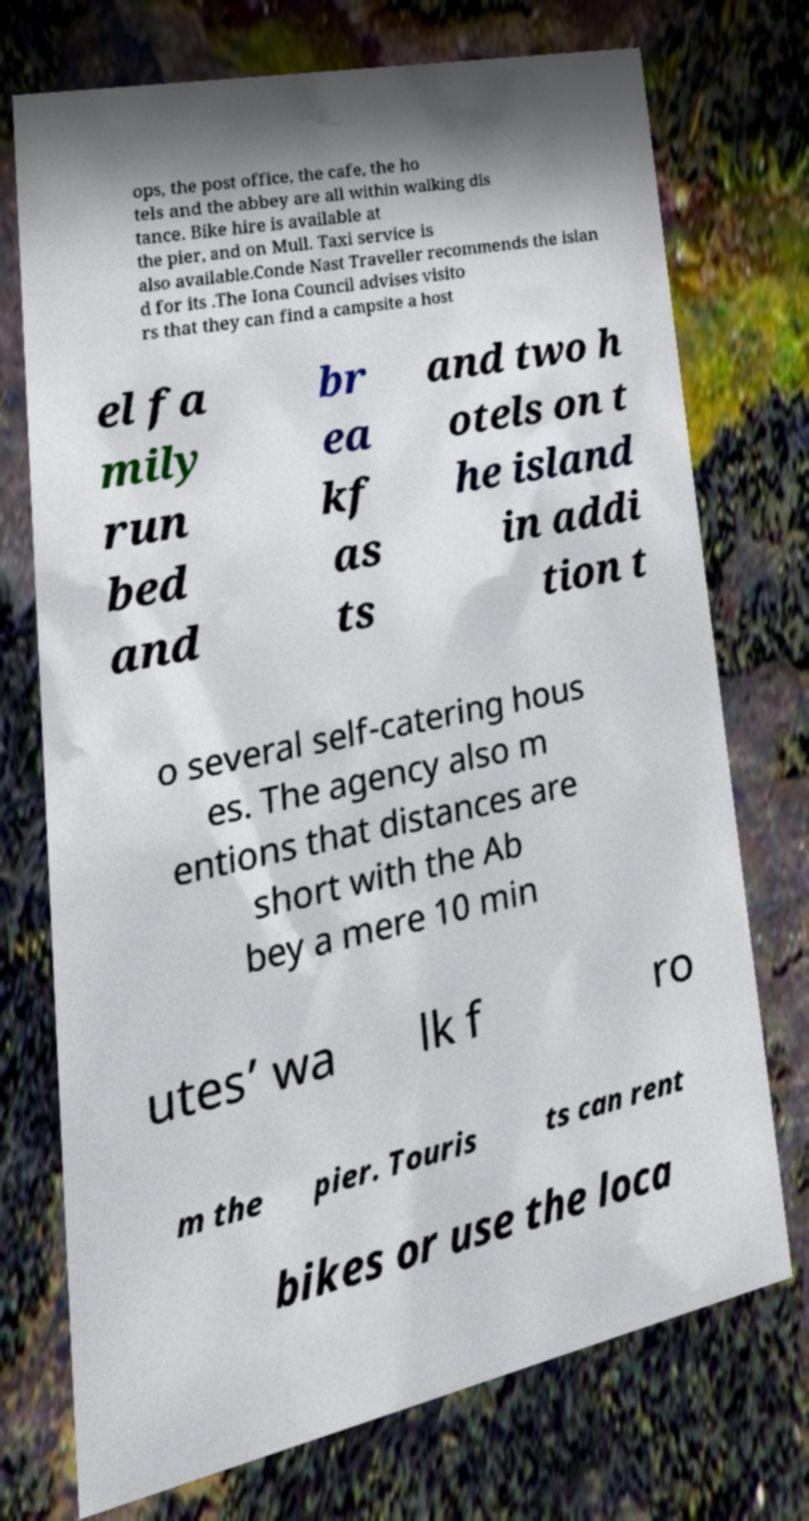Could you extract and type out the text from this image? ops, the post office, the cafe, the ho tels and the abbey are all within walking dis tance. Bike hire is available at the pier, and on Mull. Taxi service is also available.Conde Nast Traveller recommends the islan d for its .The Iona Council advises visito rs that they can find a campsite a host el fa mily run bed and br ea kf as ts and two h otels on t he island in addi tion t o several self-catering hous es. The agency also m entions that distances are short with the Ab bey a mere 10 min utes’ wa lk f ro m the pier. Touris ts can rent bikes or use the loca 